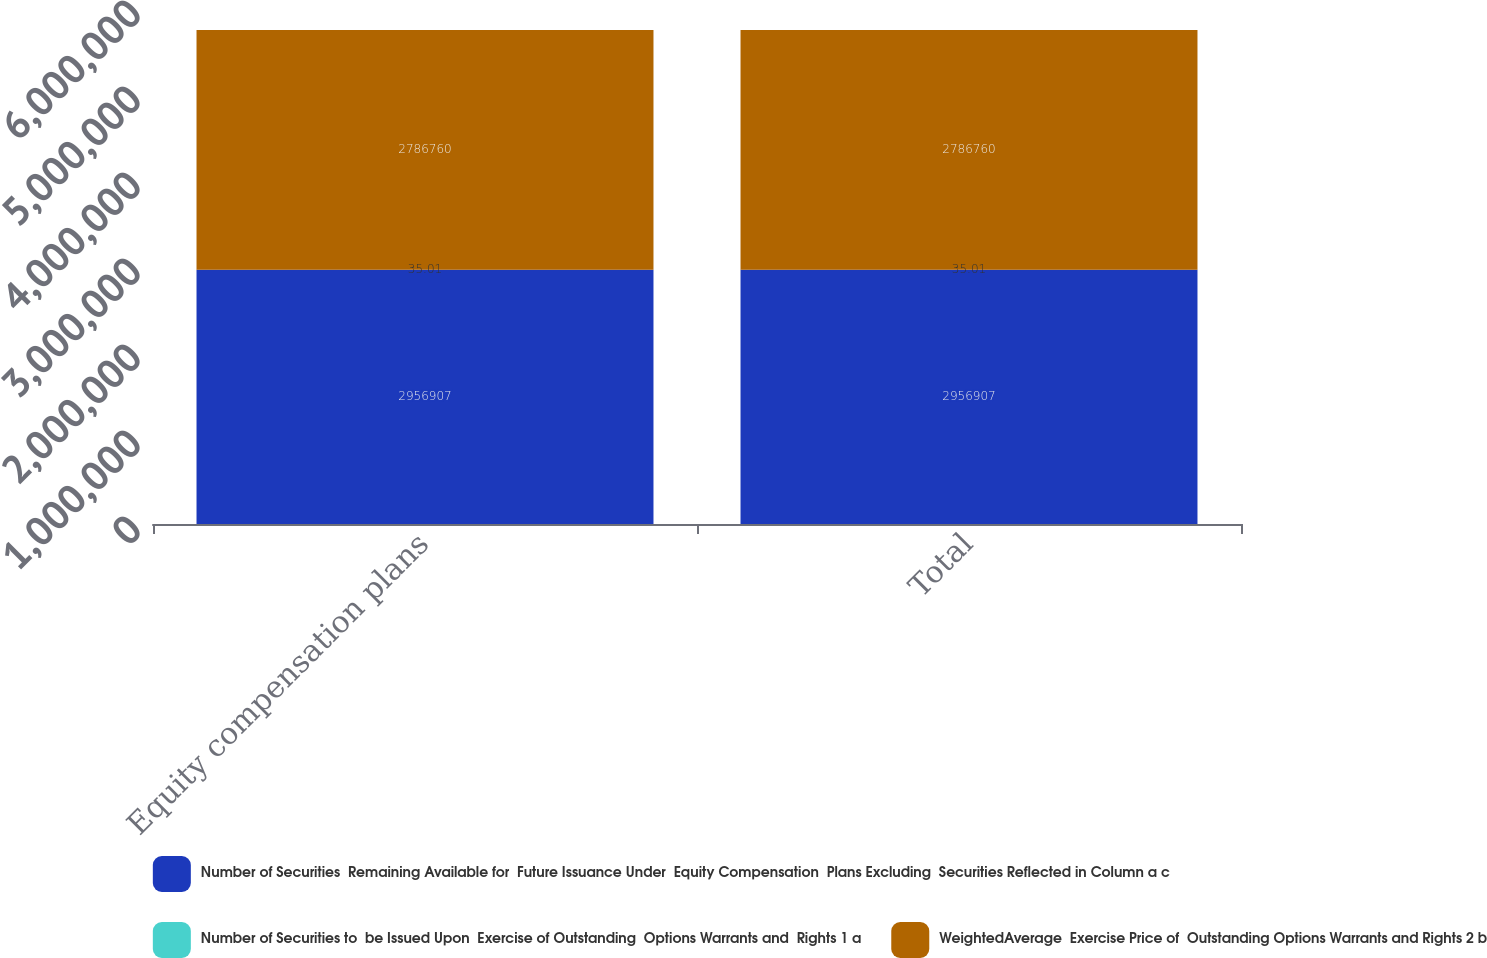Convert chart. <chart><loc_0><loc_0><loc_500><loc_500><stacked_bar_chart><ecel><fcel>Equity compensation plans<fcel>Total<nl><fcel>Number of Securities  Remaining Available for  Future Issuance Under  Equity Compensation  Plans Excluding  Securities Reflected in Column a c<fcel>2.95691e+06<fcel>2.95691e+06<nl><fcel>Number of Securities to  be Issued Upon  Exercise of Outstanding  Options Warrants and  Rights 1 a<fcel>35.01<fcel>35.01<nl><fcel>WeightedAverage  Exercise Price of  Outstanding Options Warrants and Rights 2 b<fcel>2.78676e+06<fcel>2.78676e+06<nl></chart> 